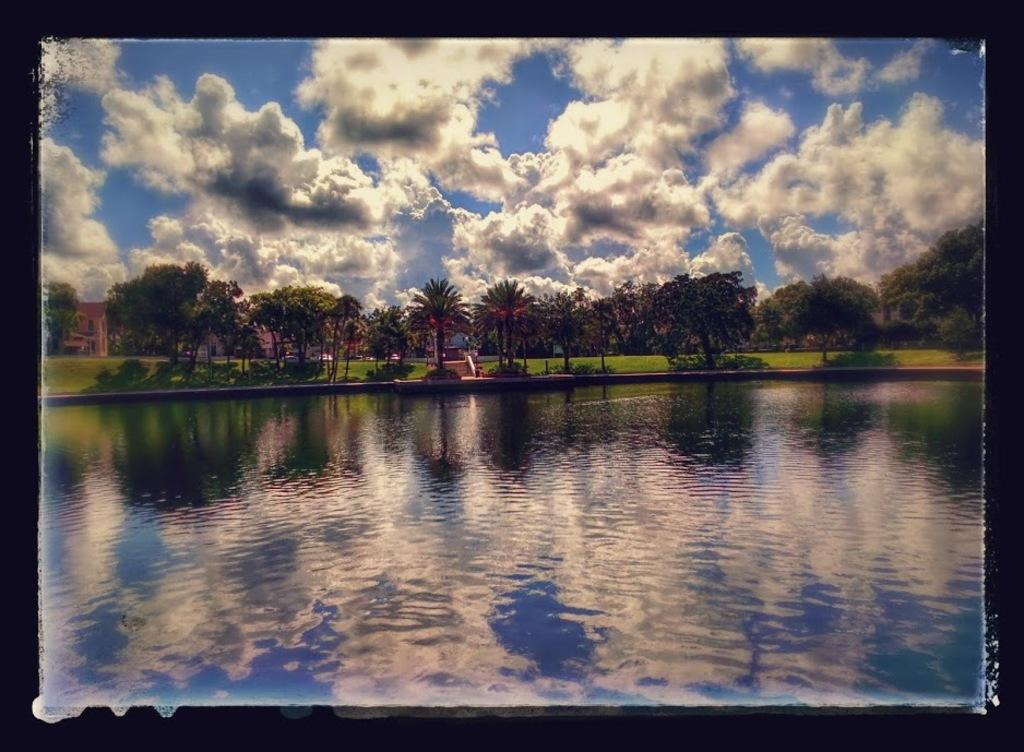What type of vegetation is present in the image? There is a group of trees in the image. What type of structures can be seen in the image? There are buildings in the image. What is visible in the foreground of the image? Water is visible in the foreground of the image. What is visible in the background of the image? The sky is visible in the background of the image. How would you describe the sky in the image? The sky appears to be cloudy. How many cups are placed on the base in the image? There are no cups or bases present in the image. What type of chickens can be seen roaming around the trees in the image? There are no chickens present in the image; it features a group of trees, buildings, water, and a cloudy sky. 